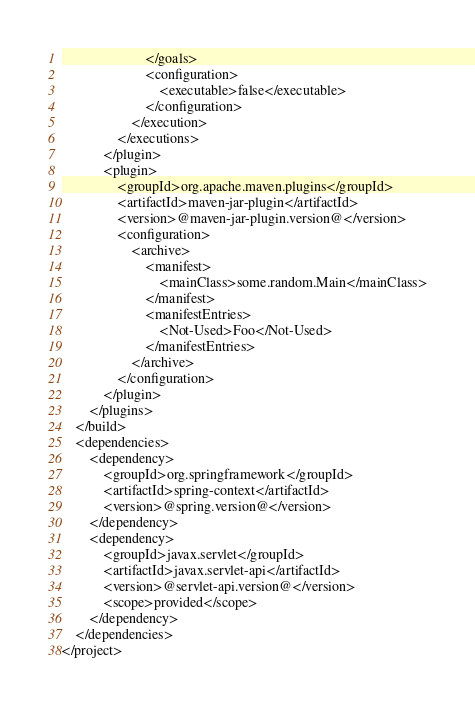Convert code to text. <code><loc_0><loc_0><loc_500><loc_500><_XML_>						</goals>
						<configuration>
							<executable>false</executable>
						</configuration>
					</execution>
				</executions>
			</plugin>
			<plugin>
				<groupId>org.apache.maven.plugins</groupId>
				<artifactId>maven-jar-plugin</artifactId>
				<version>@maven-jar-plugin.version@</version>
				<configuration>
					<archive>
						<manifest>
							<mainClass>some.random.Main</mainClass>
						</manifest>
						<manifestEntries>
							<Not-Used>Foo</Not-Used>
						</manifestEntries>
					</archive>
				</configuration>
			</plugin>
		</plugins>
	</build>
	<dependencies>
		<dependency>
			<groupId>org.springframework</groupId>
			<artifactId>spring-context</artifactId>
			<version>@spring.version@</version>
		</dependency>
		<dependency>
			<groupId>javax.servlet</groupId>
			<artifactId>javax.servlet-api</artifactId>
			<version>@servlet-api.version@</version>
			<scope>provided</scope>
		</dependency>
	</dependencies>
</project>
</code> 